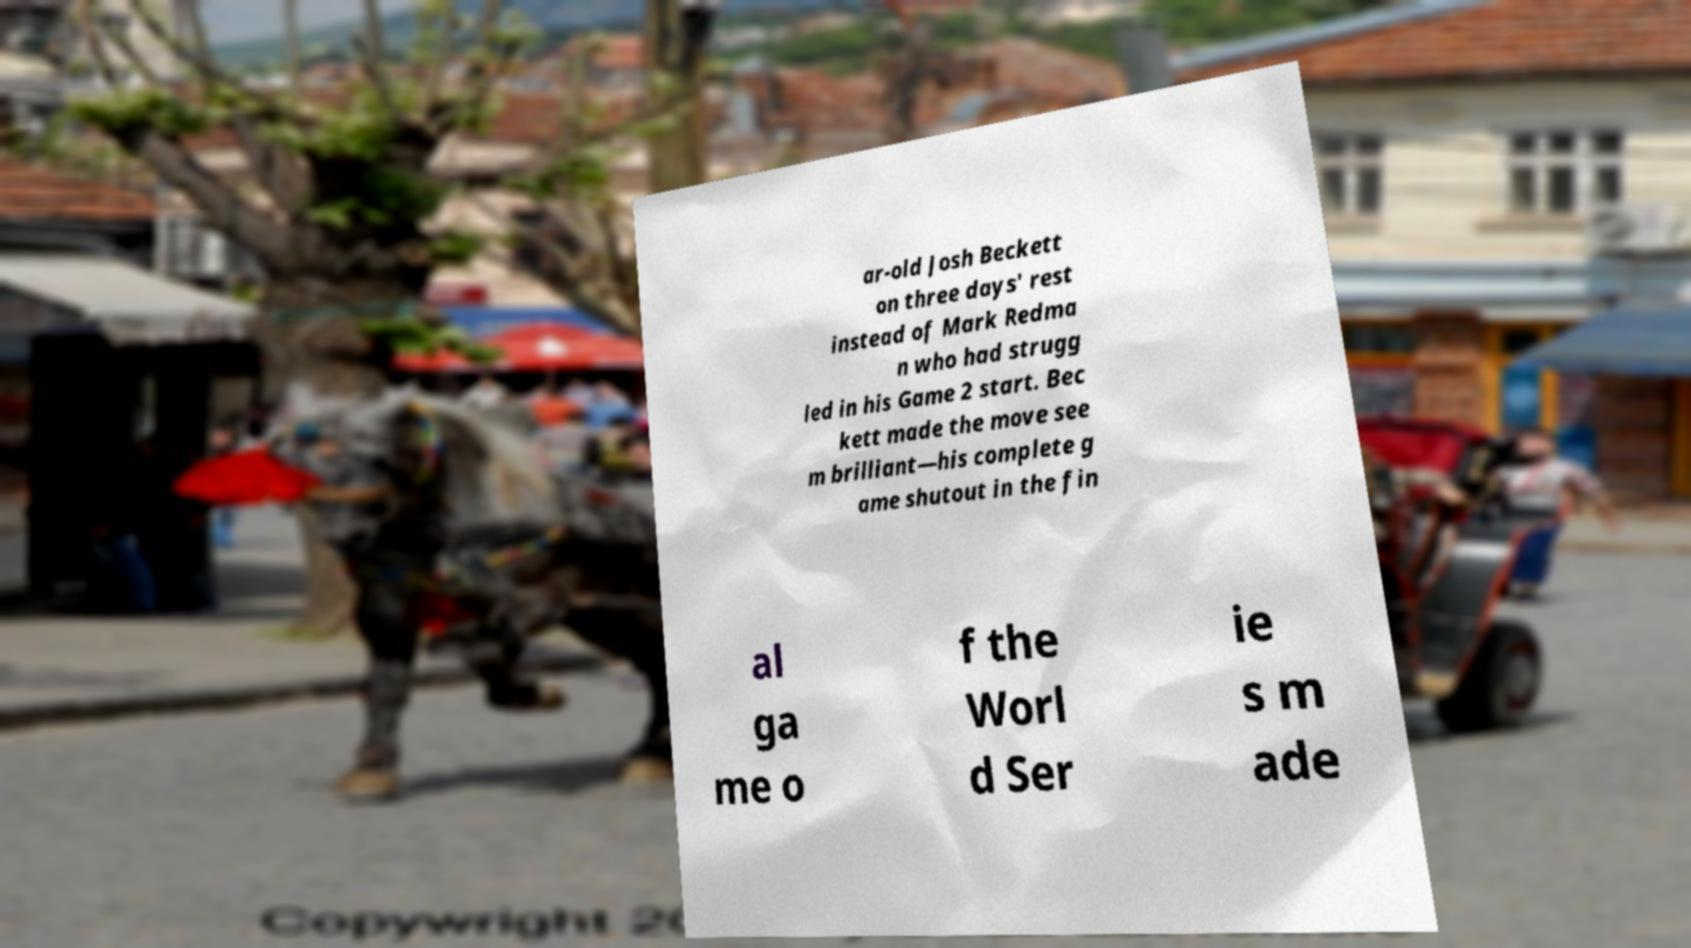Can you accurately transcribe the text from the provided image for me? ar-old Josh Beckett on three days' rest instead of Mark Redma n who had strugg led in his Game 2 start. Bec kett made the move see m brilliant—his complete g ame shutout in the fin al ga me o f the Worl d Ser ie s m ade 